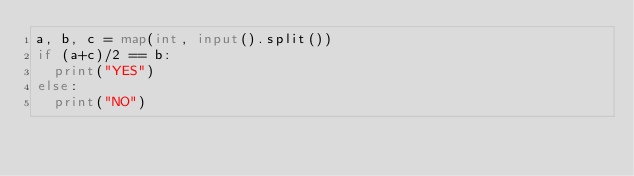<code> <loc_0><loc_0><loc_500><loc_500><_Python_>a, b, c = map(int, input().split())
if (a+c)/2 == b:
  print("YES")
else:
  print("NO")
</code> 